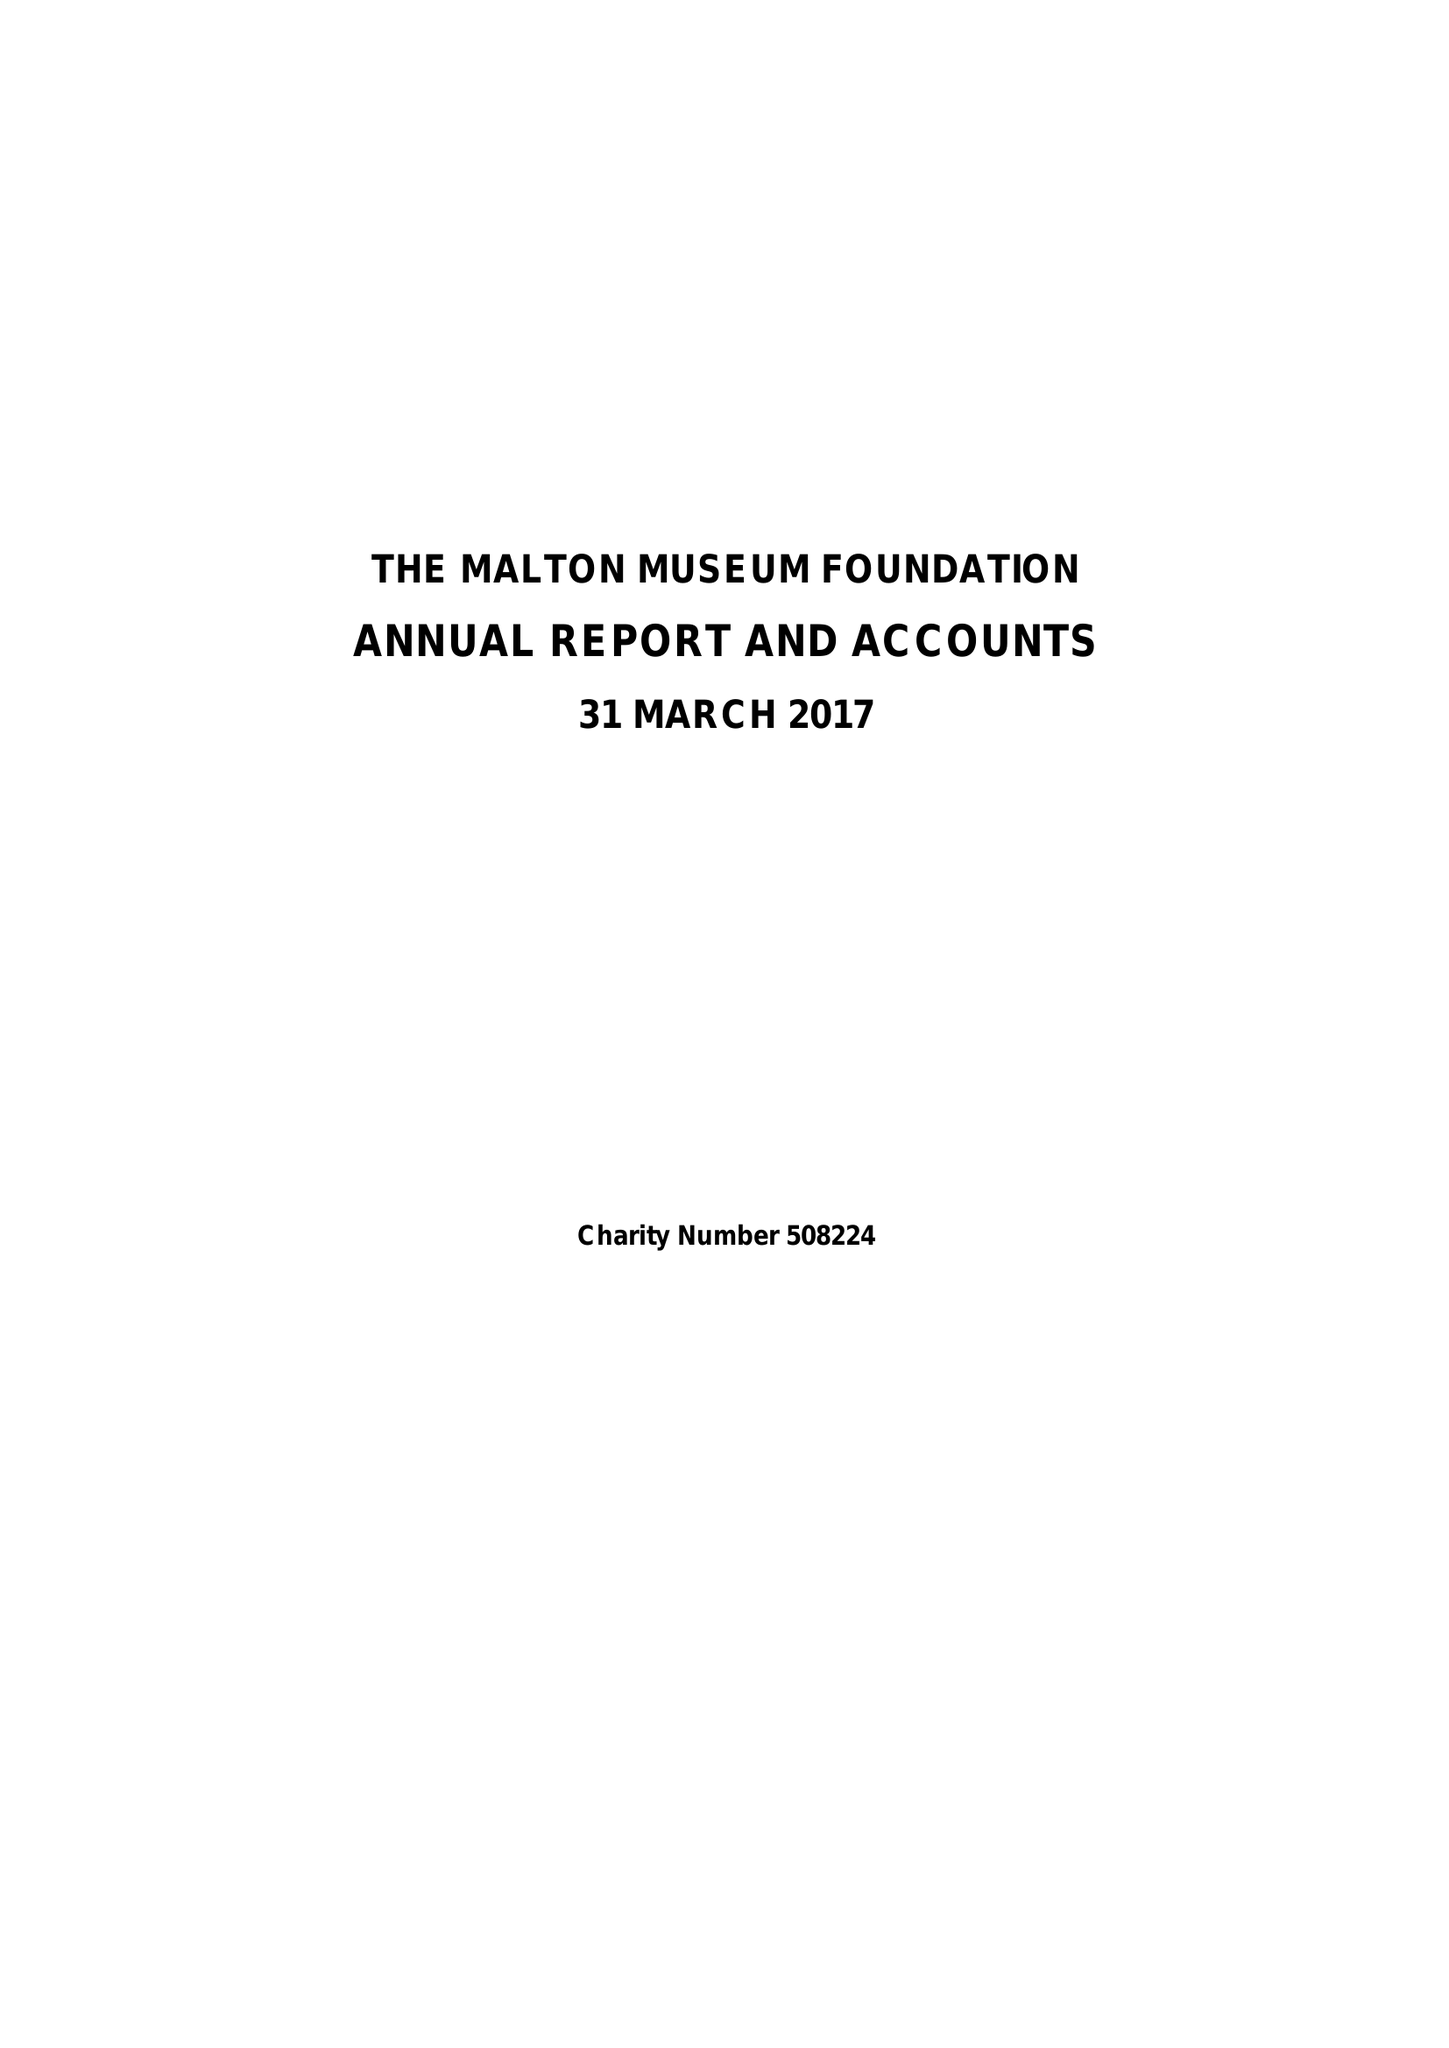What is the value for the income_annually_in_british_pounds?
Answer the question using a single word or phrase. 71818.00 